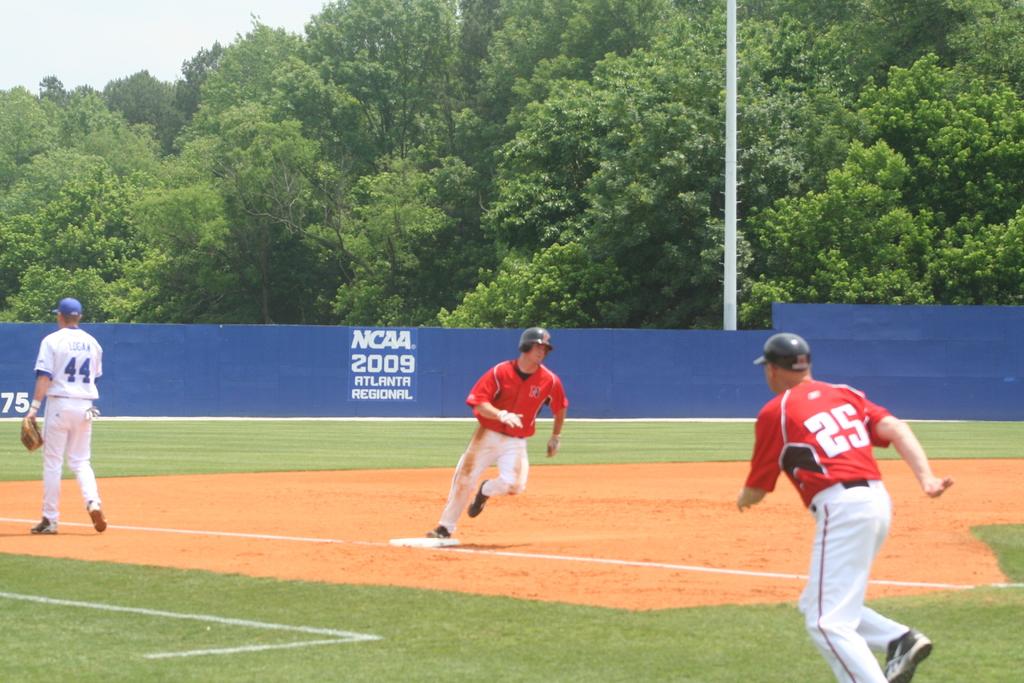What is the number of red shirt worn by the player?
Provide a short and direct response. 25. What is the player's number on the blue and white team?
Offer a very short reply. 44. 